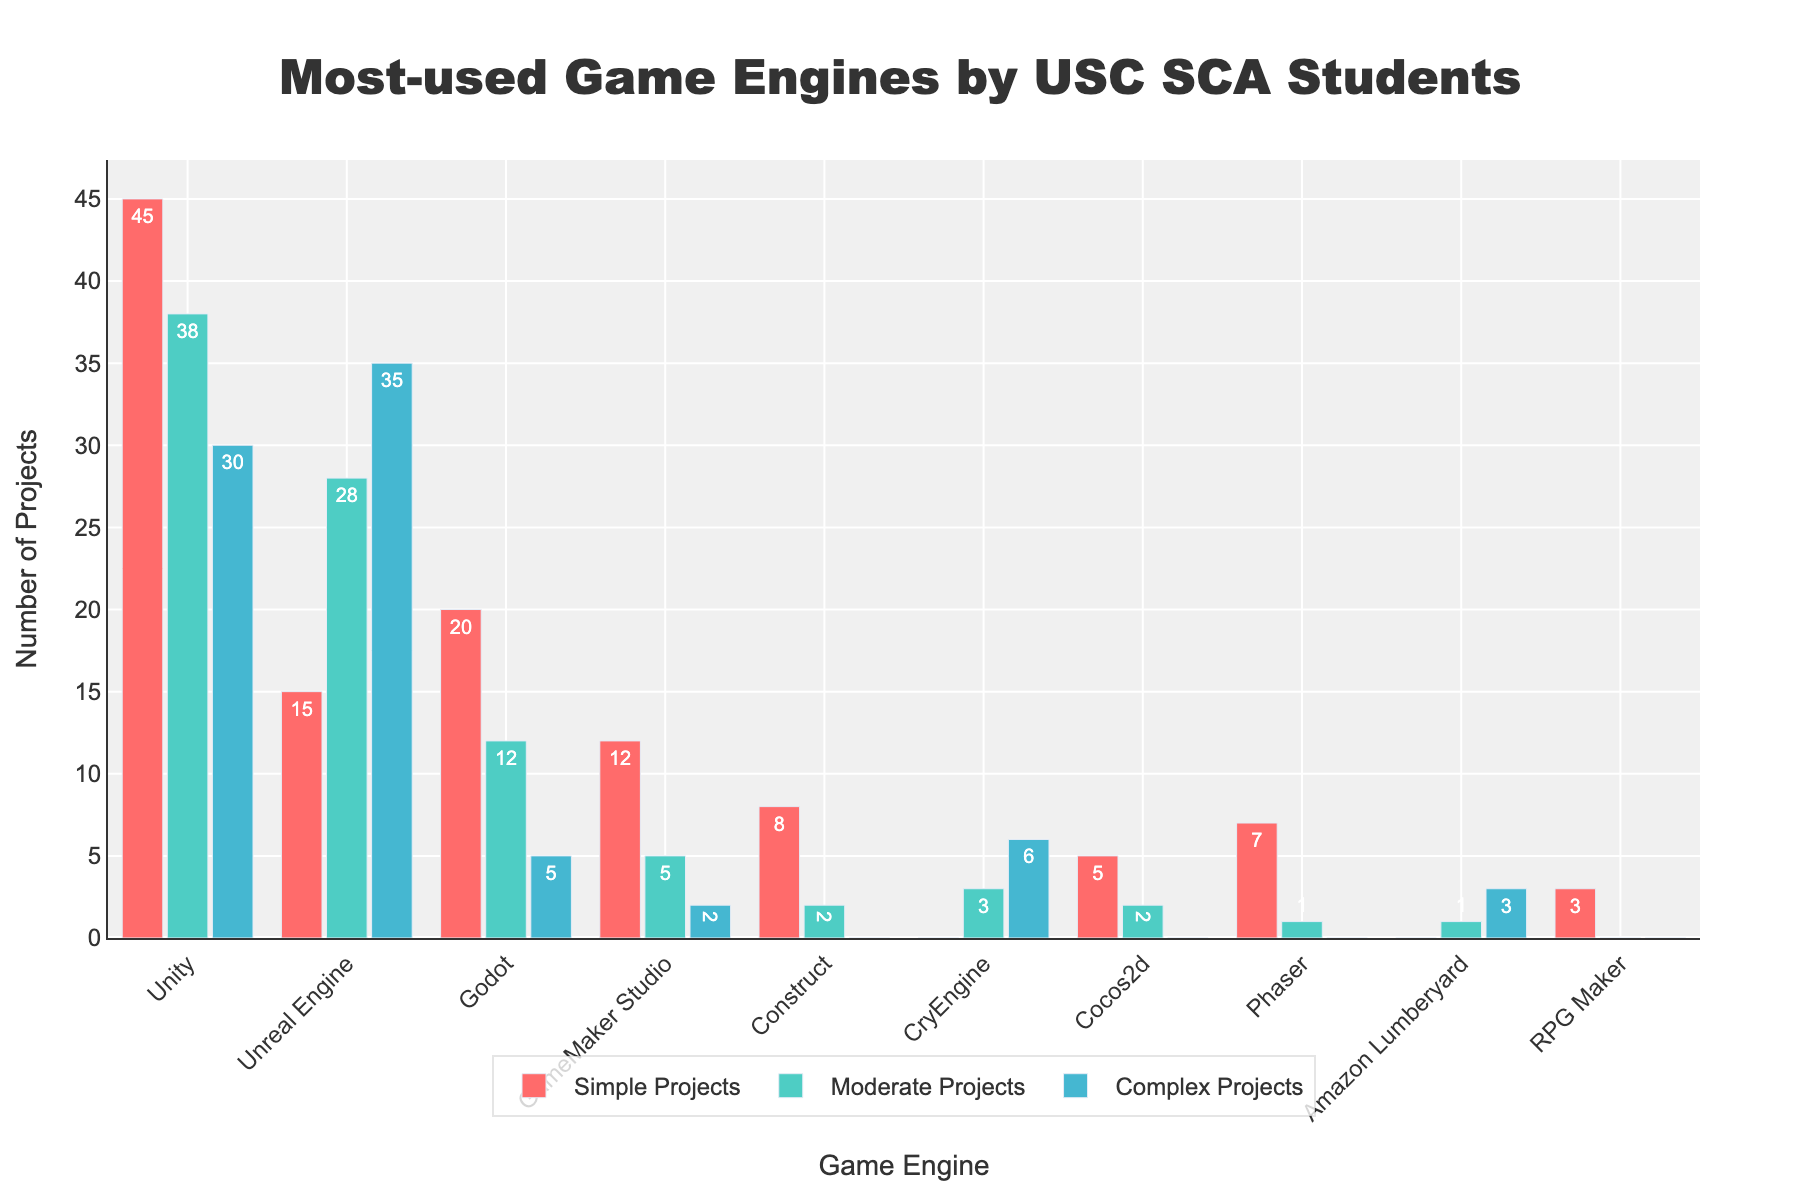what is the most used game engine for simple projects? The highest bar in the "Simple Projects" category represents the most used game engine for simple projects. The tallest bar corresponds to Unity with 45 projects.
Answer: Unity which game engine is more used for moderate projects, Unreal Engine or Godot? Comparing the height of the bars for Unreal Engine and Godot in the "Moderate Projects" category shows that Unreal Engine has 28 projects and Godot has 12.
Answer: Unreal Engine what is the total number of projects using Unity? Sum the counts of Unity across all categories: Simple Projects (45) + Moderate Projects (38) + Complex Projects (30). Therefore, the total is 113.
Answer: 113 how many more simple projects use Unity compared to GameMaker Studio? Subtract the number of projects for GameMaker Studio (12) from those for Unity (45) in the "Simple Projects" category: 45 - 12 = 33.
Answer: 33 what percentage of complex projects use the Unreal Engine? First, find the total number of complex projects across all engines: Unity (30) + Unreal Engine (35) + Godot (5) + GameMaker Studio (2) + Construct (0) + CryEngine (6) + Cocos2d (0) + Phaser (0) + Amazon Lumberyard (3) + RPG Maker (0) = 81. Then calculate the percentage for Unreal Engine: (35 / 81) * 100 ≈ 43.21%.
Answer: 43.21% which engine shows the highest variety in the number of projects across different complexities? Compare the range (difference between maximum and minimum values) of projects for each engine across the three categories. Unity has the range of 45 (Simple) - 30 (Complex) = 15. Other engines have smaller ranges.
Answer: Unity which game engine is exclusively used for complex projects among the given list? A bar that shows value only in the "Complex Projects" category and zero in others. CryEngine meets this criterion with 3 entries in Complex and 0 in Simple and Moderate projects.
Answer: CryEngine what is the average number of projects for Godot across all categories? Sum the counts and divide by the number of categories: (20 + 12 + 5) / 3 = 37 / 3 = 12.33.
Answer: 12.33 how many fewer moderate projects are there for GameMaker Studio compared to CryEngine? Subtract the number of projects for CryEngine (3) from those for GameMaker Studio (5) in "Moderate Projects": 5 - 3 = 2.
Answer: 2 how many projects in total use engines other than Unity? Sum the counts for all other engines: Unreal Engine (78) + Godot (37) + GameMaker Studio (19) + Construct (10) + CryEngine (9) + Cocos2d (7) + Phaser (8) + Amazon Lumberyard (4) + RPG Maker (3). The total is 175.
Answer: 175 